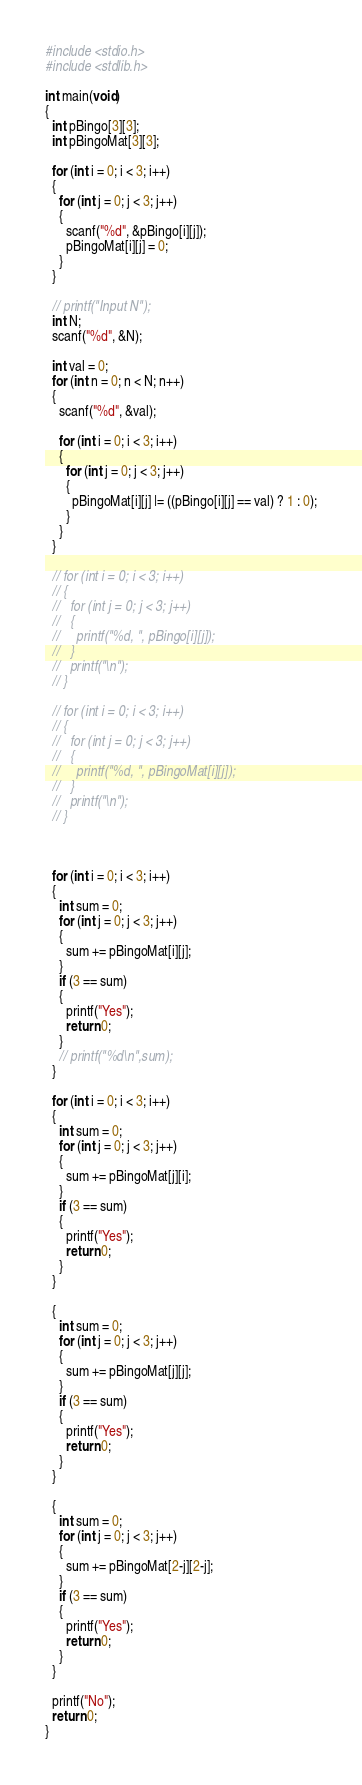<code> <loc_0><loc_0><loc_500><loc_500><_C_>#include <stdio.h>
#include <stdlib.h>

int main(void)
{
  int pBingo[3][3];
  int pBingoMat[3][3];

  for (int i = 0; i < 3; i++)
  {
    for (int j = 0; j < 3; j++)
    {
      scanf("%d", &pBingo[i][j]);
      pBingoMat[i][j] = 0;
    }
  }

  // printf("Input N");
  int N;
  scanf("%d", &N);

  int val = 0;
  for (int n = 0; n < N; n++)
  {
    scanf("%d", &val);

    for (int i = 0; i < 3; i++)
    {
      for (int j = 0; j < 3; j++)
      {
        pBingoMat[i][j] |= ((pBingo[i][j] == val) ? 1 : 0);
      } 
    }
  }

  // for (int i = 0; i < 3; i++)
  // {
  //   for (int j = 0; j < 3; j++)
  //   {
  //     printf("%d, ", pBingo[i][j]);
  //   } 
  //   printf("\n");
  // }

  // for (int i = 0; i < 3; i++)
  // {
  //   for (int j = 0; j < 3; j++)
  //   {
  //     printf("%d, ", pBingoMat[i][j]);
  //   } 
  //   printf("\n");
  // }



  for (int i = 0; i < 3; i++)
  {
    int sum = 0;
    for (int j = 0; j < 3; j++)
    {
      sum += pBingoMat[i][j];
    }
    if (3 == sum)
    {
      printf("Yes");
      return 0;
    }
    // printf("%d\n",sum);
  }

  for (int i = 0; i < 3; i++)
  {
    int sum = 0;
    for (int j = 0; j < 3; j++)
    {
      sum += pBingoMat[j][i];
    }
    if (3 == sum)
    {
      printf("Yes");
      return 0;
    }
  }

  {
    int sum = 0;
    for (int j = 0; j < 3; j++)
    {
      sum += pBingoMat[j][j];
    }
    if (3 == sum)
    {
      printf("Yes");
      return 0;
    }
  }

  {
    int sum = 0;
    for (int j = 0; j < 3; j++)
    {
      sum += pBingoMat[2-j][2-j];
    }
    if (3 == sum)
    {
      printf("Yes");
      return 0;
    }
  }

  printf("No");
  return 0;
}</code> 